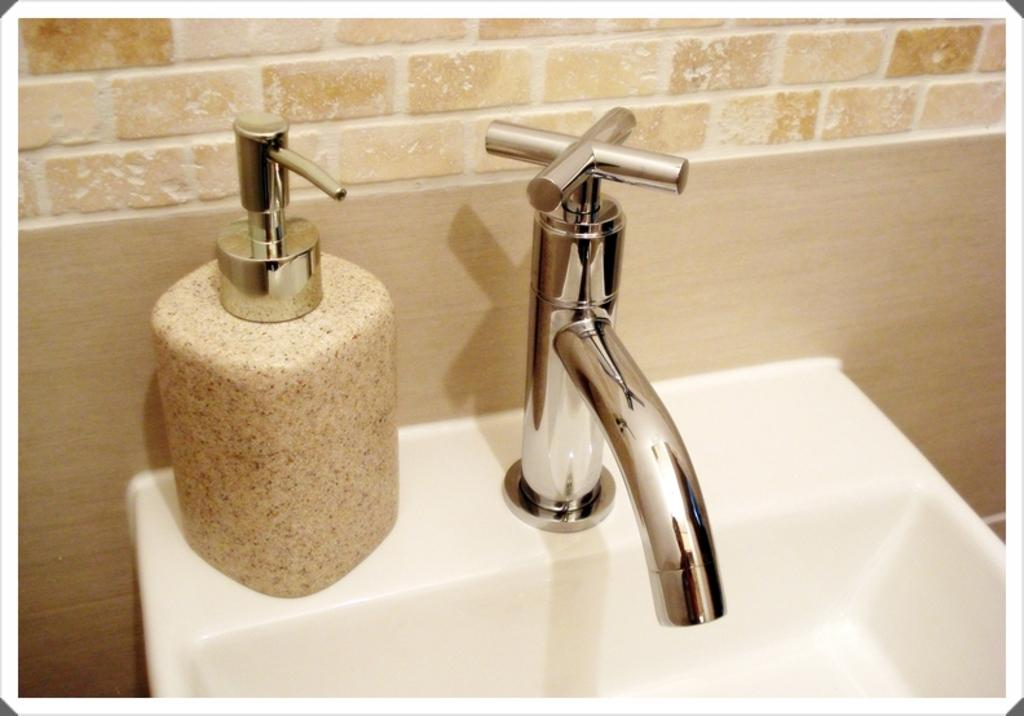What can be found in the image for washing purposes? There is a sink in the image. What is attached to the sink for water flow? There is a tap on the sink. What is located near the sink in the image? There is a bottle beside the sink. What can be seen in the background of the image? There is a wall in the background of the image. What type of fowl can be seen performing magic in the image? There is no fowl or magic present in the image; it features a sink, a tap, a bottle, and a wall in the background. 